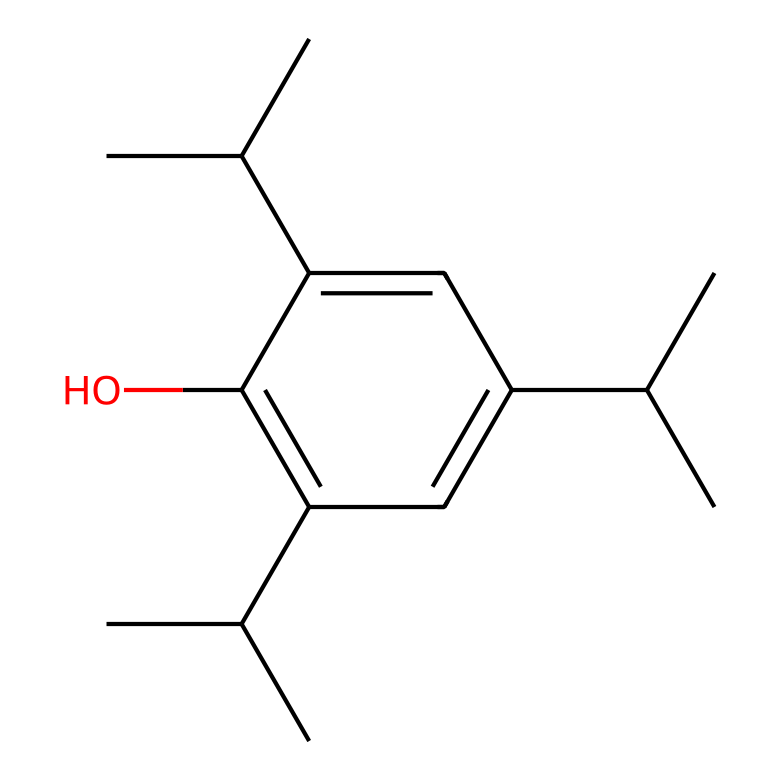What is the total number of carbon atoms in this compound? By analyzing the SMILES representation and the structure it describes, we identify each carbon atom represented. In this SMILES, there are 15 carbon atoms.
Answer: 15 How many hydroxyl (OH) groups does this chemical contain? A hydroxyl group consists of an oxygen atom bonded to a hydrogen atom (−OH). Looking closely at the structure in the SMILES, there is one instance of a carbon bonded to a hydroxyl group, indicating one OH group.
Answer: 1 What type of functional group is indicated by the presence of "C(C)C" and "O" in this molecule? The presence of the "C(C)C" indicates branched alkyl groups and the "O" indicates the presence of a hydroxyl group, making it an alcohol due to the -OH functional group present on one of the carbon atoms.
Answer: alcohol What is the overall molecular formula based on the structure from the SMILES? To derive the molecular formula, count the carbon (C), hydrogen (H), and oxygen (O) atoms. There are 15 carbon atoms, 28 hydrogen atoms, and 1 oxygen atom, giving the formula C15H28O.
Answer: C15H28O What indicates that this compound could be used as an anesthetic in terms of chemical properties? Anesthetic compounds often have non-polar characteristics, and this structure features multiple branched alkyl groups and a hydrophobic character due to the large number of carbon and hydrogen atoms without excessive electronegative atoms.
Answer: hydrophobic character 